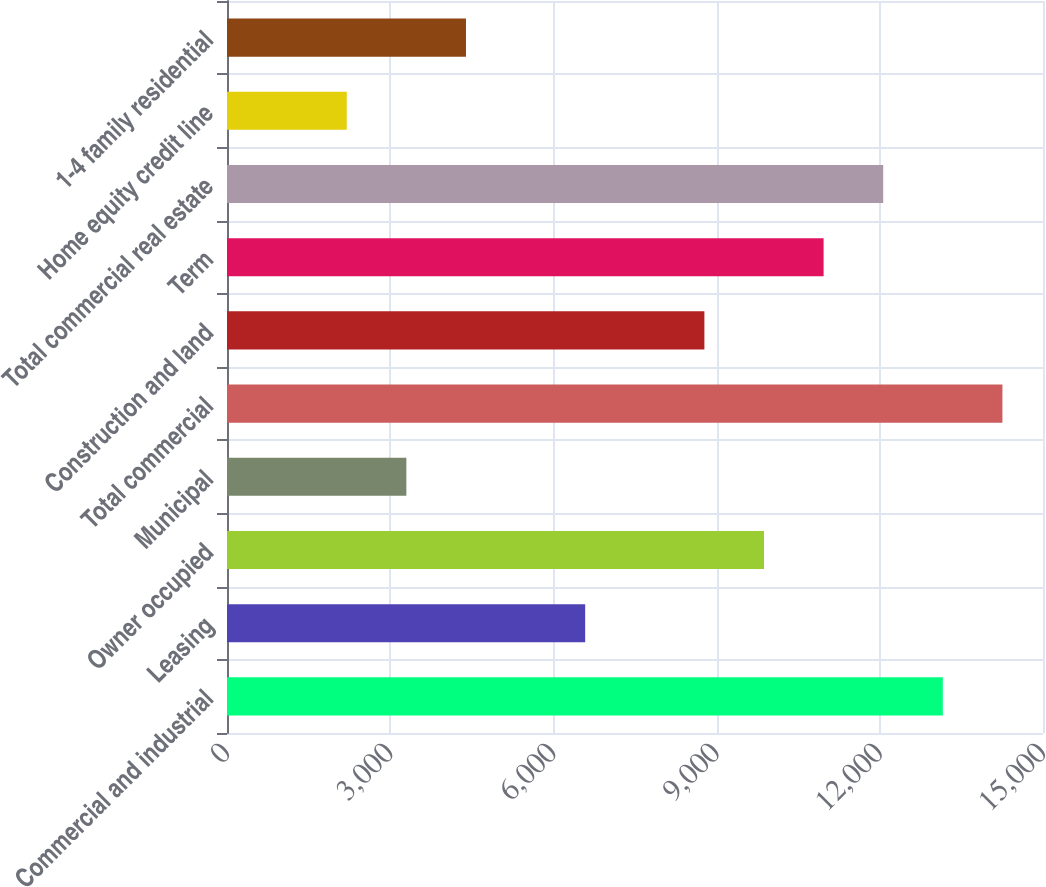Convert chart. <chart><loc_0><loc_0><loc_500><loc_500><bar_chart><fcel>Commercial and industrial<fcel>Leasing<fcel>Owner occupied<fcel>Municipal<fcel>Total commercial<fcel>Construction and land<fcel>Term<fcel>Total commercial real estate<fcel>Home equity credit line<fcel>1-4 family residential<nl><fcel>13158.4<fcel>6584.2<fcel>9871.3<fcel>3297.1<fcel>14254.1<fcel>8775.6<fcel>10967<fcel>12062.7<fcel>2201.4<fcel>4392.8<nl></chart> 